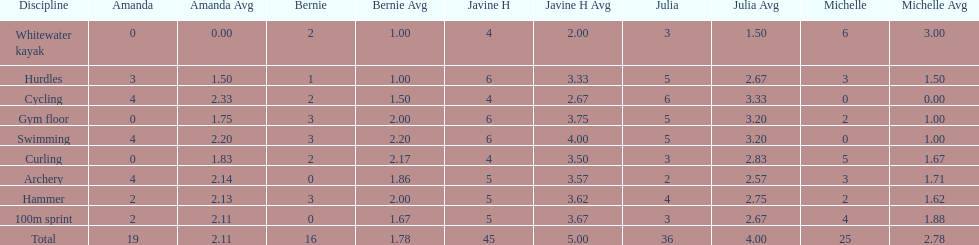Can you mention a girl who obtained equal points in cycling and archery competitions? Amanda. 